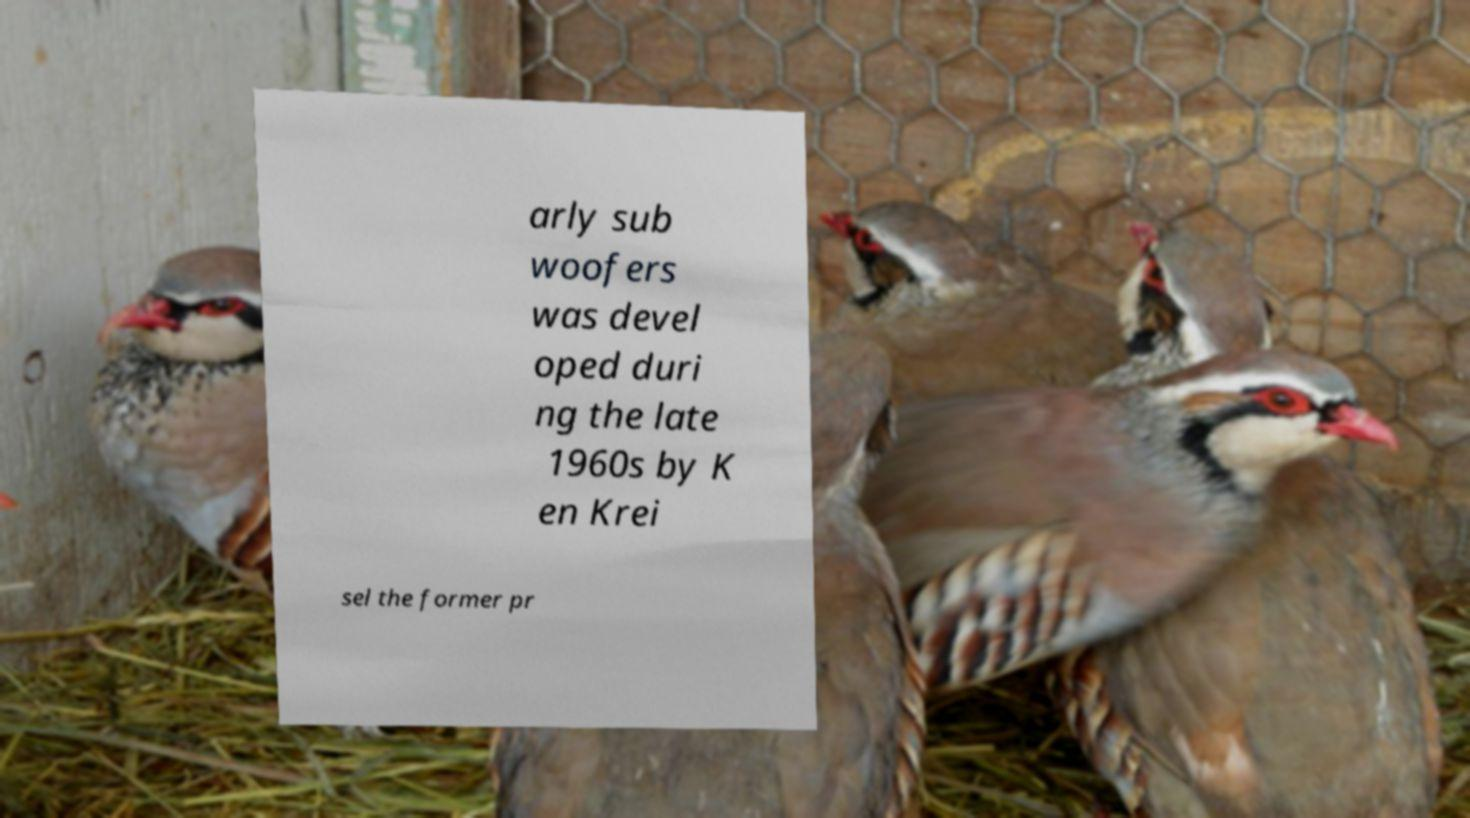Please read and relay the text visible in this image. What does it say? arly sub woofers was devel oped duri ng the late 1960s by K en Krei sel the former pr 